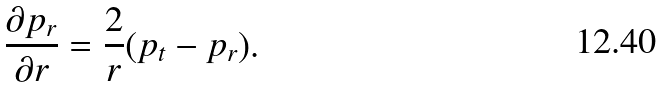Convert formula to latex. <formula><loc_0><loc_0><loc_500><loc_500>\frac { \partial p _ { r } } { \partial r } = \frac { 2 } { r } ( p _ { t } - p _ { r } ) .</formula> 